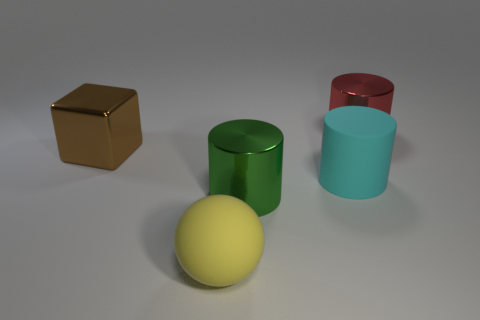What is the relative size of the yellow sphere compared to the cylinders? The yellow sphere appears to be slightly smaller in diameter compared to the base of the cylinders, making it relatively smaller in size. 